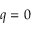Convert formula to latex. <formula><loc_0><loc_0><loc_500><loc_500>q = 0</formula> 